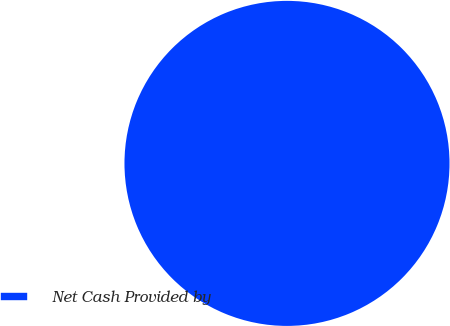Convert chart. <chart><loc_0><loc_0><loc_500><loc_500><pie_chart><fcel>Net Cash Provided by<nl><fcel>100.0%<nl></chart> 